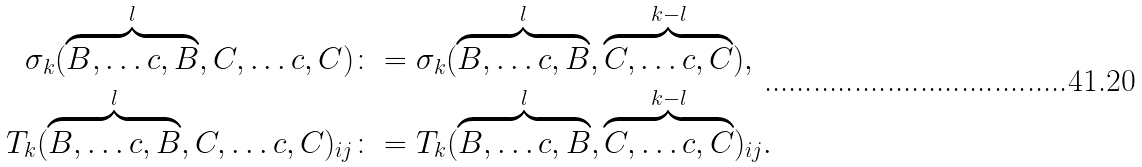Convert formula to latex. <formula><loc_0><loc_0><loc_500><loc_500>\sigma _ { k } ( \overbrace { B , \dots c , B } ^ { l } , C , \dots c , C ) & \colon = \sigma _ { k } ( \overbrace { B , \dots c , B } ^ { l } , \overbrace { C , \dots c , C } ^ { k - l } ) , \\ T _ { k } ( \overbrace { B , \dots c , B } ^ { l } , C , \dots c , C ) _ { i j } & \colon = T _ { k } ( \overbrace { B , \dots c , B } ^ { l } , \overbrace { C , \dots c , C } ^ { k - l } ) _ { i j } .</formula> 